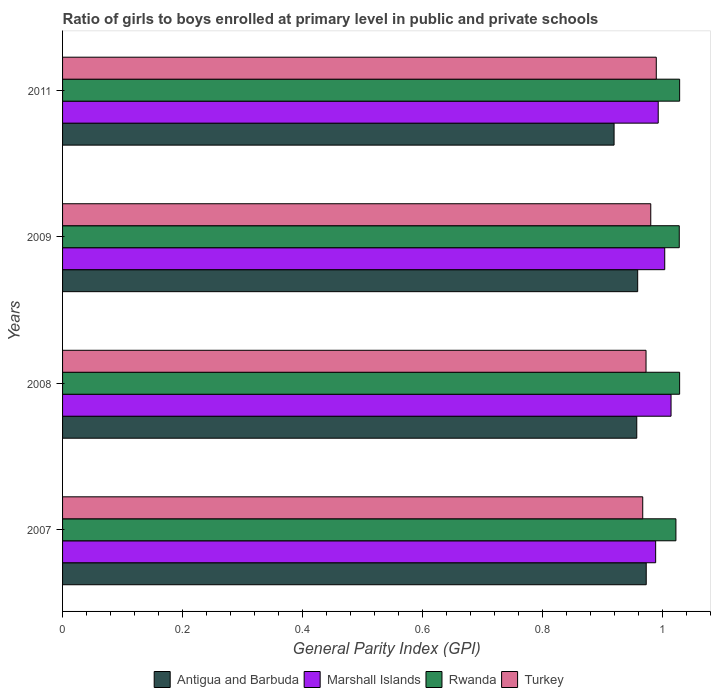How many groups of bars are there?
Provide a short and direct response. 4. Are the number of bars per tick equal to the number of legend labels?
Give a very brief answer. Yes. Are the number of bars on each tick of the Y-axis equal?
Keep it short and to the point. Yes. How many bars are there on the 2nd tick from the top?
Keep it short and to the point. 4. In how many cases, is the number of bars for a given year not equal to the number of legend labels?
Offer a very short reply. 0. What is the general parity index in Turkey in 2007?
Offer a terse response. 0.97. Across all years, what is the maximum general parity index in Rwanda?
Give a very brief answer. 1.03. Across all years, what is the minimum general parity index in Turkey?
Your answer should be compact. 0.97. In which year was the general parity index in Rwanda minimum?
Keep it short and to the point. 2007. What is the total general parity index in Marshall Islands in the graph?
Your answer should be compact. 4. What is the difference between the general parity index in Turkey in 2007 and that in 2008?
Offer a very short reply. -0.01. What is the difference between the general parity index in Antigua and Barbuda in 2011 and the general parity index in Marshall Islands in 2008?
Keep it short and to the point. -0.1. What is the average general parity index in Turkey per year?
Your answer should be compact. 0.98. In the year 2011, what is the difference between the general parity index in Marshall Islands and general parity index in Turkey?
Offer a terse response. 0. In how many years, is the general parity index in Rwanda greater than 0.44 ?
Offer a terse response. 4. What is the ratio of the general parity index in Turkey in 2007 to that in 2009?
Make the answer very short. 0.99. What is the difference between the highest and the second highest general parity index in Antigua and Barbuda?
Give a very brief answer. 0.01. What is the difference between the highest and the lowest general parity index in Antigua and Barbuda?
Your answer should be very brief. 0.05. Is the sum of the general parity index in Antigua and Barbuda in 2007 and 2008 greater than the maximum general parity index in Turkey across all years?
Make the answer very short. Yes. What does the 3rd bar from the bottom in 2009 represents?
Ensure brevity in your answer.  Rwanda. Is it the case that in every year, the sum of the general parity index in Turkey and general parity index in Rwanda is greater than the general parity index in Antigua and Barbuda?
Offer a very short reply. Yes. How many bars are there?
Provide a succinct answer. 16. What is the difference between two consecutive major ticks on the X-axis?
Offer a terse response. 0.2. Are the values on the major ticks of X-axis written in scientific E-notation?
Keep it short and to the point. No. How many legend labels are there?
Provide a short and direct response. 4. What is the title of the graph?
Offer a terse response. Ratio of girls to boys enrolled at primary level in public and private schools. Does "Congo (Republic)" appear as one of the legend labels in the graph?
Offer a terse response. No. What is the label or title of the X-axis?
Offer a terse response. General Parity Index (GPI). What is the label or title of the Y-axis?
Ensure brevity in your answer.  Years. What is the General Parity Index (GPI) in Antigua and Barbuda in 2007?
Your answer should be compact. 0.97. What is the General Parity Index (GPI) in Marshall Islands in 2007?
Offer a very short reply. 0.99. What is the General Parity Index (GPI) in Rwanda in 2007?
Ensure brevity in your answer.  1.02. What is the General Parity Index (GPI) of Turkey in 2007?
Ensure brevity in your answer.  0.97. What is the General Parity Index (GPI) in Antigua and Barbuda in 2008?
Your answer should be compact. 0.96. What is the General Parity Index (GPI) in Marshall Islands in 2008?
Offer a terse response. 1.01. What is the General Parity Index (GPI) in Rwanda in 2008?
Your response must be concise. 1.03. What is the General Parity Index (GPI) of Turkey in 2008?
Your response must be concise. 0.97. What is the General Parity Index (GPI) of Antigua and Barbuda in 2009?
Ensure brevity in your answer.  0.96. What is the General Parity Index (GPI) of Marshall Islands in 2009?
Give a very brief answer. 1. What is the General Parity Index (GPI) of Rwanda in 2009?
Provide a succinct answer. 1.03. What is the General Parity Index (GPI) in Turkey in 2009?
Ensure brevity in your answer.  0.98. What is the General Parity Index (GPI) in Antigua and Barbuda in 2011?
Keep it short and to the point. 0.92. What is the General Parity Index (GPI) of Marshall Islands in 2011?
Keep it short and to the point. 0.99. What is the General Parity Index (GPI) in Rwanda in 2011?
Provide a short and direct response. 1.03. What is the General Parity Index (GPI) of Turkey in 2011?
Your answer should be compact. 0.99. Across all years, what is the maximum General Parity Index (GPI) of Antigua and Barbuda?
Ensure brevity in your answer.  0.97. Across all years, what is the maximum General Parity Index (GPI) of Marshall Islands?
Your answer should be very brief. 1.01. Across all years, what is the maximum General Parity Index (GPI) in Rwanda?
Provide a short and direct response. 1.03. Across all years, what is the maximum General Parity Index (GPI) of Turkey?
Offer a terse response. 0.99. Across all years, what is the minimum General Parity Index (GPI) in Antigua and Barbuda?
Your answer should be compact. 0.92. Across all years, what is the minimum General Parity Index (GPI) of Marshall Islands?
Offer a very short reply. 0.99. Across all years, what is the minimum General Parity Index (GPI) in Rwanda?
Keep it short and to the point. 1.02. Across all years, what is the minimum General Parity Index (GPI) in Turkey?
Provide a short and direct response. 0.97. What is the total General Parity Index (GPI) of Antigua and Barbuda in the graph?
Your answer should be very brief. 3.81. What is the total General Parity Index (GPI) in Marshall Islands in the graph?
Offer a terse response. 4. What is the total General Parity Index (GPI) in Rwanda in the graph?
Offer a very short reply. 4.11. What is the total General Parity Index (GPI) in Turkey in the graph?
Your answer should be very brief. 3.91. What is the difference between the General Parity Index (GPI) in Antigua and Barbuda in 2007 and that in 2008?
Your response must be concise. 0.02. What is the difference between the General Parity Index (GPI) of Marshall Islands in 2007 and that in 2008?
Give a very brief answer. -0.03. What is the difference between the General Parity Index (GPI) of Rwanda in 2007 and that in 2008?
Ensure brevity in your answer.  -0.01. What is the difference between the General Parity Index (GPI) in Turkey in 2007 and that in 2008?
Give a very brief answer. -0.01. What is the difference between the General Parity Index (GPI) of Antigua and Barbuda in 2007 and that in 2009?
Your answer should be compact. 0.01. What is the difference between the General Parity Index (GPI) in Marshall Islands in 2007 and that in 2009?
Give a very brief answer. -0.02. What is the difference between the General Parity Index (GPI) in Rwanda in 2007 and that in 2009?
Make the answer very short. -0.01. What is the difference between the General Parity Index (GPI) of Turkey in 2007 and that in 2009?
Provide a succinct answer. -0.01. What is the difference between the General Parity Index (GPI) in Antigua and Barbuda in 2007 and that in 2011?
Ensure brevity in your answer.  0.05. What is the difference between the General Parity Index (GPI) of Marshall Islands in 2007 and that in 2011?
Offer a terse response. -0. What is the difference between the General Parity Index (GPI) in Rwanda in 2007 and that in 2011?
Your response must be concise. -0.01. What is the difference between the General Parity Index (GPI) in Turkey in 2007 and that in 2011?
Give a very brief answer. -0.02. What is the difference between the General Parity Index (GPI) in Antigua and Barbuda in 2008 and that in 2009?
Offer a terse response. -0. What is the difference between the General Parity Index (GPI) in Marshall Islands in 2008 and that in 2009?
Offer a terse response. 0.01. What is the difference between the General Parity Index (GPI) in Rwanda in 2008 and that in 2009?
Give a very brief answer. 0. What is the difference between the General Parity Index (GPI) of Turkey in 2008 and that in 2009?
Your response must be concise. -0.01. What is the difference between the General Parity Index (GPI) in Antigua and Barbuda in 2008 and that in 2011?
Your response must be concise. 0.04. What is the difference between the General Parity Index (GPI) in Marshall Islands in 2008 and that in 2011?
Provide a succinct answer. 0.02. What is the difference between the General Parity Index (GPI) of Rwanda in 2008 and that in 2011?
Provide a short and direct response. -0. What is the difference between the General Parity Index (GPI) of Turkey in 2008 and that in 2011?
Provide a short and direct response. -0.02. What is the difference between the General Parity Index (GPI) in Antigua and Barbuda in 2009 and that in 2011?
Keep it short and to the point. 0.04. What is the difference between the General Parity Index (GPI) of Marshall Islands in 2009 and that in 2011?
Offer a terse response. 0.01. What is the difference between the General Parity Index (GPI) in Rwanda in 2009 and that in 2011?
Provide a succinct answer. -0. What is the difference between the General Parity Index (GPI) in Turkey in 2009 and that in 2011?
Offer a very short reply. -0.01. What is the difference between the General Parity Index (GPI) of Antigua and Barbuda in 2007 and the General Parity Index (GPI) of Marshall Islands in 2008?
Offer a very short reply. -0.04. What is the difference between the General Parity Index (GPI) in Antigua and Barbuda in 2007 and the General Parity Index (GPI) in Rwanda in 2008?
Offer a very short reply. -0.06. What is the difference between the General Parity Index (GPI) in Antigua and Barbuda in 2007 and the General Parity Index (GPI) in Turkey in 2008?
Offer a terse response. 0. What is the difference between the General Parity Index (GPI) of Marshall Islands in 2007 and the General Parity Index (GPI) of Rwanda in 2008?
Your answer should be compact. -0.04. What is the difference between the General Parity Index (GPI) of Marshall Islands in 2007 and the General Parity Index (GPI) of Turkey in 2008?
Provide a short and direct response. 0.02. What is the difference between the General Parity Index (GPI) of Rwanda in 2007 and the General Parity Index (GPI) of Turkey in 2008?
Give a very brief answer. 0.05. What is the difference between the General Parity Index (GPI) in Antigua and Barbuda in 2007 and the General Parity Index (GPI) in Marshall Islands in 2009?
Offer a very short reply. -0.03. What is the difference between the General Parity Index (GPI) of Antigua and Barbuda in 2007 and the General Parity Index (GPI) of Rwanda in 2009?
Provide a short and direct response. -0.06. What is the difference between the General Parity Index (GPI) of Antigua and Barbuda in 2007 and the General Parity Index (GPI) of Turkey in 2009?
Your response must be concise. -0.01. What is the difference between the General Parity Index (GPI) in Marshall Islands in 2007 and the General Parity Index (GPI) in Rwanda in 2009?
Your answer should be compact. -0.04. What is the difference between the General Parity Index (GPI) of Marshall Islands in 2007 and the General Parity Index (GPI) of Turkey in 2009?
Make the answer very short. 0.01. What is the difference between the General Parity Index (GPI) of Rwanda in 2007 and the General Parity Index (GPI) of Turkey in 2009?
Provide a short and direct response. 0.04. What is the difference between the General Parity Index (GPI) of Antigua and Barbuda in 2007 and the General Parity Index (GPI) of Marshall Islands in 2011?
Your answer should be very brief. -0.02. What is the difference between the General Parity Index (GPI) of Antigua and Barbuda in 2007 and the General Parity Index (GPI) of Rwanda in 2011?
Ensure brevity in your answer.  -0.06. What is the difference between the General Parity Index (GPI) of Antigua and Barbuda in 2007 and the General Parity Index (GPI) of Turkey in 2011?
Keep it short and to the point. -0.02. What is the difference between the General Parity Index (GPI) in Marshall Islands in 2007 and the General Parity Index (GPI) in Rwanda in 2011?
Your answer should be compact. -0.04. What is the difference between the General Parity Index (GPI) in Marshall Islands in 2007 and the General Parity Index (GPI) in Turkey in 2011?
Offer a terse response. -0. What is the difference between the General Parity Index (GPI) in Rwanda in 2007 and the General Parity Index (GPI) in Turkey in 2011?
Offer a very short reply. 0.03. What is the difference between the General Parity Index (GPI) in Antigua and Barbuda in 2008 and the General Parity Index (GPI) in Marshall Islands in 2009?
Your response must be concise. -0.05. What is the difference between the General Parity Index (GPI) in Antigua and Barbuda in 2008 and the General Parity Index (GPI) in Rwanda in 2009?
Give a very brief answer. -0.07. What is the difference between the General Parity Index (GPI) in Antigua and Barbuda in 2008 and the General Parity Index (GPI) in Turkey in 2009?
Provide a short and direct response. -0.02. What is the difference between the General Parity Index (GPI) of Marshall Islands in 2008 and the General Parity Index (GPI) of Rwanda in 2009?
Make the answer very short. -0.01. What is the difference between the General Parity Index (GPI) in Marshall Islands in 2008 and the General Parity Index (GPI) in Turkey in 2009?
Your answer should be compact. 0.03. What is the difference between the General Parity Index (GPI) in Rwanda in 2008 and the General Parity Index (GPI) in Turkey in 2009?
Provide a short and direct response. 0.05. What is the difference between the General Parity Index (GPI) in Antigua and Barbuda in 2008 and the General Parity Index (GPI) in Marshall Islands in 2011?
Offer a terse response. -0.04. What is the difference between the General Parity Index (GPI) of Antigua and Barbuda in 2008 and the General Parity Index (GPI) of Rwanda in 2011?
Your answer should be compact. -0.07. What is the difference between the General Parity Index (GPI) in Antigua and Barbuda in 2008 and the General Parity Index (GPI) in Turkey in 2011?
Give a very brief answer. -0.03. What is the difference between the General Parity Index (GPI) in Marshall Islands in 2008 and the General Parity Index (GPI) in Rwanda in 2011?
Ensure brevity in your answer.  -0.01. What is the difference between the General Parity Index (GPI) in Marshall Islands in 2008 and the General Parity Index (GPI) in Turkey in 2011?
Give a very brief answer. 0.02. What is the difference between the General Parity Index (GPI) in Rwanda in 2008 and the General Parity Index (GPI) in Turkey in 2011?
Keep it short and to the point. 0.04. What is the difference between the General Parity Index (GPI) of Antigua and Barbuda in 2009 and the General Parity Index (GPI) of Marshall Islands in 2011?
Offer a very short reply. -0.03. What is the difference between the General Parity Index (GPI) of Antigua and Barbuda in 2009 and the General Parity Index (GPI) of Rwanda in 2011?
Your answer should be compact. -0.07. What is the difference between the General Parity Index (GPI) of Antigua and Barbuda in 2009 and the General Parity Index (GPI) of Turkey in 2011?
Provide a short and direct response. -0.03. What is the difference between the General Parity Index (GPI) in Marshall Islands in 2009 and the General Parity Index (GPI) in Rwanda in 2011?
Keep it short and to the point. -0.02. What is the difference between the General Parity Index (GPI) of Marshall Islands in 2009 and the General Parity Index (GPI) of Turkey in 2011?
Provide a short and direct response. 0.01. What is the difference between the General Parity Index (GPI) in Rwanda in 2009 and the General Parity Index (GPI) in Turkey in 2011?
Provide a short and direct response. 0.04. What is the average General Parity Index (GPI) of Antigua and Barbuda per year?
Provide a short and direct response. 0.95. What is the average General Parity Index (GPI) in Rwanda per year?
Ensure brevity in your answer.  1.03. What is the average General Parity Index (GPI) of Turkey per year?
Provide a short and direct response. 0.98. In the year 2007, what is the difference between the General Parity Index (GPI) of Antigua and Barbuda and General Parity Index (GPI) of Marshall Islands?
Offer a terse response. -0.02. In the year 2007, what is the difference between the General Parity Index (GPI) of Antigua and Barbuda and General Parity Index (GPI) of Rwanda?
Ensure brevity in your answer.  -0.05. In the year 2007, what is the difference between the General Parity Index (GPI) of Antigua and Barbuda and General Parity Index (GPI) of Turkey?
Give a very brief answer. 0.01. In the year 2007, what is the difference between the General Parity Index (GPI) of Marshall Islands and General Parity Index (GPI) of Rwanda?
Provide a short and direct response. -0.03. In the year 2007, what is the difference between the General Parity Index (GPI) in Marshall Islands and General Parity Index (GPI) in Turkey?
Your response must be concise. 0.02. In the year 2007, what is the difference between the General Parity Index (GPI) of Rwanda and General Parity Index (GPI) of Turkey?
Your answer should be very brief. 0.06. In the year 2008, what is the difference between the General Parity Index (GPI) in Antigua and Barbuda and General Parity Index (GPI) in Marshall Islands?
Offer a very short reply. -0.06. In the year 2008, what is the difference between the General Parity Index (GPI) of Antigua and Barbuda and General Parity Index (GPI) of Rwanda?
Provide a succinct answer. -0.07. In the year 2008, what is the difference between the General Parity Index (GPI) of Antigua and Barbuda and General Parity Index (GPI) of Turkey?
Your answer should be compact. -0.02. In the year 2008, what is the difference between the General Parity Index (GPI) in Marshall Islands and General Parity Index (GPI) in Rwanda?
Keep it short and to the point. -0.01. In the year 2008, what is the difference between the General Parity Index (GPI) in Marshall Islands and General Parity Index (GPI) in Turkey?
Your answer should be very brief. 0.04. In the year 2008, what is the difference between the General Parity Index (GPI) of Rwanda and General Parity Index (GPI) of Turkey?
Offer a very short reply. 0.06. In the year 2009, what is the difference between the General Parity Index (GPI) in Antigua and Barbuda and General Parity Index (GPI) in Marshall Islands?
Your answer should be very brief. -0.05. In the year 2009, what is the difference between the General Parity Index (GPI) of Antigua and Barbuda and General Parity Index (GPI) of Rwanda?
Give a very brief answer. -0.07. In the year 2009, what is the difference between the General Parity Index (GPI) of Antigua and Barbuda and General Parity Index (GPI) of Turkey?
Your answer should be very brief. -0.02. In the year 2009, what is the difference between the General Parity Index (GPI) of Marshall Islands and General Parity Index (GPI) of Rwanda?
Offer a very short reply. -0.02. In the year 2009, what is the difference between the General Parity Index (GPI) of Marshall Islands and General Parity Index (GPI) of Turkey?
Keep it short and to the point. 0.02. In the year 2009, what is the difference between the General Parity Index (GPI) in Rwanda and General Parity Index (GPI) in Turkey?
Your response must be concise. 0.05. In the year 2011, what is the difference between the General Parity Index (GPI) in Antigua and Barbuda and General Parity Index (GPI) in Marshall Islands?
Keep it short and to the point. -0.07. In the year 2011, what is the difference between the General Parity Index (GPI) in Antigua and Barbuda and General Parity Index (GPI) in Rwanda?
Provide a succinct answer. -0.11. In the year 2011, what is the difference between the General Parity Index (GPI) of Antigua and Barbuda and General Parity Index (GPI) of Turkey?
Keep it short and to the point. -0.07. In the year 2011, what is the difference between the General Parity Index (GPI) in Marshall Islands and General Parity Index (GPI) in Rwanda?
Give a very brief answer. -0.04. In the year 2011, what is the difference between the General Parity Index (GPI) of Marshall Islands and General Parity Index (GPI) of Turkey?
Provide a succinct answer. 0. In the year 2011, what is the difference between the General Parity Index (GPI) in Rwanda and General Parity Index (GPI) in Turkey?
Keep it short and to the point. 0.04. What is the ratio of the General Parity Index (GPI) in Antigua and Barbuda in 2007 to that in 2008?
Your answer should be compact. 1.02. What is the ratio of the General Parity Index (GPI) of Marshall Islands in 2007 to that in 2008?
Make the answer very short. 0.97. What is the ratio of the General Parity Index (GPI) in Turkey in 2007 to that in 2008?
Provide a succinct answer. 0.99. What is the ratio of the General Parity Index (GPI) of Antigua and Barbuda in 2007 to that in 2009?
Your answer should be compact. 1.01. What is the ratio of the General Parity Index (GPI) in Marshall Islands in 2007 to that in 2009?
Offer a terse response. 0.98. What is the ratio of the General Parity Index (GPI) of Rwanda in 2007 to that in 2009?
Provide a succinct answer. 0.99. What is the ratio of the General Parity Index (GPI) of Turkey in 2007 to that in 2009?
Your answer should be compact. 0.99. What is the ratio of the General Parity Index (GPI) of Antigua and Barbuda in 2007 to that in 2011?
Make the answer very short. 1.06. What is the ratio of the General Parity Index (GPI) of Rwanda in 2007 to that in 2011?
Keep it short and to the point. 0.99. What is the ratio of the General Parity Index (GPI) of Turkey in 2007 to that in 2011?
Your answer should be compact. 0.98. What is the ratio of the General Parity Index (GPI) of Marshall Islands in 2008 to that in 2009?
Your answer should be compact. 1.01. What is the ratio of the General Parity Index (GPI) in Turkey in 2008 to that in 2009?
Ensure brevity in your answer.  0.99. What is the ratio of the General Parity Index (GPI) in Antigua and Barbuda in 2008 to that in 2011?
Your response must be concise. 1.04. What is the ratio of the General Parity Index (GPI) in Marshall Islands in 2008 to that in 2011?
Ensure brevity in your answer.  1.02. What is the ratio of the General Parity Index (GPI) of Rwanda in 2008 to that in 2011?
Keep it short and to the point. 1. What is the ratio of the General Parity Index (GPI) of Turkey in 2008 to that in 2011?
Give a very brief answer. 0.98. What is the ratio of the General Parity Index (GPI) of Antigua and Barbuda in 2009 to that in 2011?
Provide a succinct answer. 1.04. What is the ratio of the General Parity Index (GPI) of Rwanda in 2009 to that in 2011?
Offer a terse response. 1. What is the difference between the highest and the second highest General Parity Index (GPI) of Antigua and Barbuda?
Provide a short and direct response. 0.01. What is the difference between the highest and the second highest General Parity Index (GPI) of Marshall Islands?
Provide a succinct answer. 0.01. What is the difference between the highest and the second highest General Parity Index (GPI) in Turkey?
Provide a succinct answer. 0.01. What is the difference between the highest and the lowest General Parity Index (GPI) of Antigua and Barbuda?
Your answer should be compact. 0.05. What is the difference between the highest and the lowest General Parity Index (GPI) of Marshall Islands?
Your response must be concise. 0.03. What is the difference between the highest and the lowest General Parity Index (GPI) of Rwanda?
Offer a very short reply. 0.01. What is the difference between the highest and the lowest General Parity Index (GPI) in Turkey?
Give a very brief answer. 0.02. 